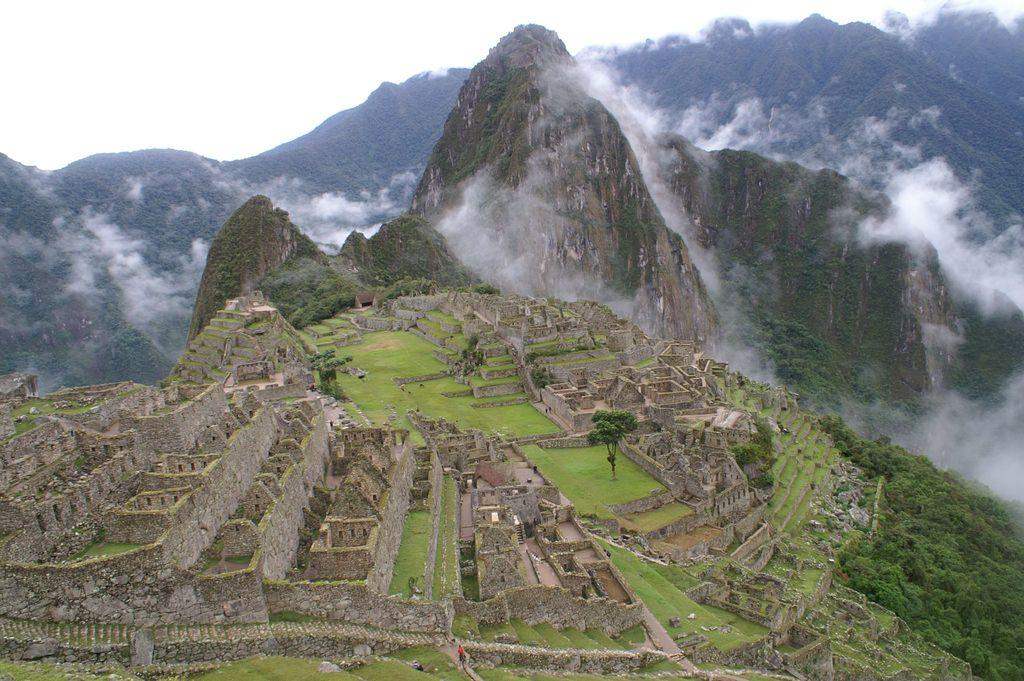What perspective is the image taken from? The image shows a top view of a city. What is the condition of the city in the image? The city appears to be ruined. What natural features can be seen in the image? There are mountains visible in the image. What is the weather like in the image? Clouds are present around the mountains, suggesting a possible overcast or cloudy condition. What company is responsible for pushing the mountains in the image? There is no company or action of pushing mountains present in the image. 